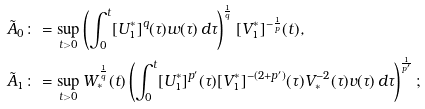<formula> <loc_0><loc_0><loc_500><loc_500>\tilde { A } _ { 0 } \colon & = \sup _ { t > 0 } \left ( \int _ { 0 } ^ { t } [ U _ { 1 } ^ { * } ] ^ { q } ( \tau ) w ( \tau ) \, d \tau \right ) ^ { \frac { 1 } { q } } [ V _ { 1 } ^ { * } ] ^ { - \frac { 1 } { p } } ( t ) , \\ \tilde { A } _ { 1 } \colon & = \sup _ { t > 0 } W _ { * } ^ { \frac { 1 } { q } } ( t ) \left ( \int _ { 0 } ^ { t } [ U _ { 1 } ^ { * } ] ^ { p ^ { \prime } } ( \tau ) [ V _ { 1 } ^ { * } ] ^ { - ( 2 + p ^ { \prime } ) } ( \tau ) V _ { * } ^ { - 2 } ( \tau ) v ( \tau ) \, d \tau \right ) ^ { \frac { 1 } { p ^ { \prime } } } ;</formula> 